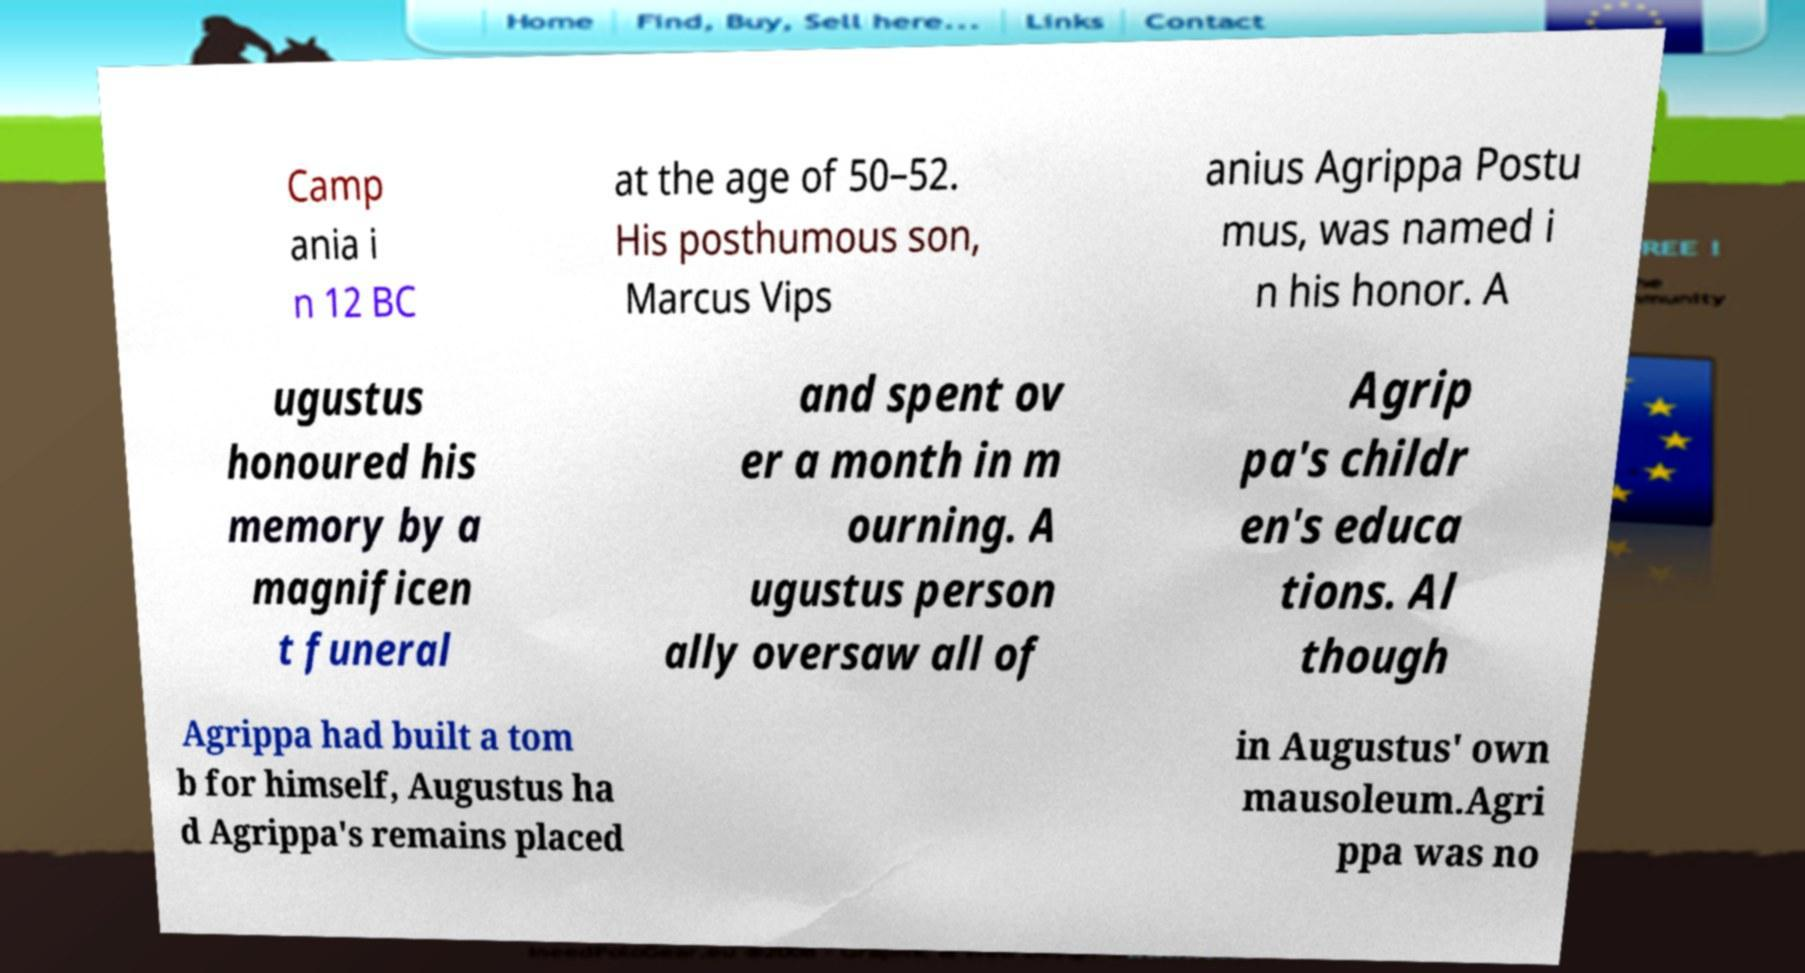For documentation purposes, I need the text within this image transcribed. Could you provide that? Camp ania i n 12 BC at the age of 50–52. His posthumous son, Marcus Vips anius Agrippa Postu mus, was named i n his honor. A ugustus honoured his memory by a magnificen t funeral and spent ov er a month in m ourning. A ugustus person ally oversaw all of Agrip pa's childr en's educa tions. Al though Agrippa had built a tom b for himself, Augustus ha d Agrippa's remains placed in Augustus' own mausoleum.Agri ppa was no 